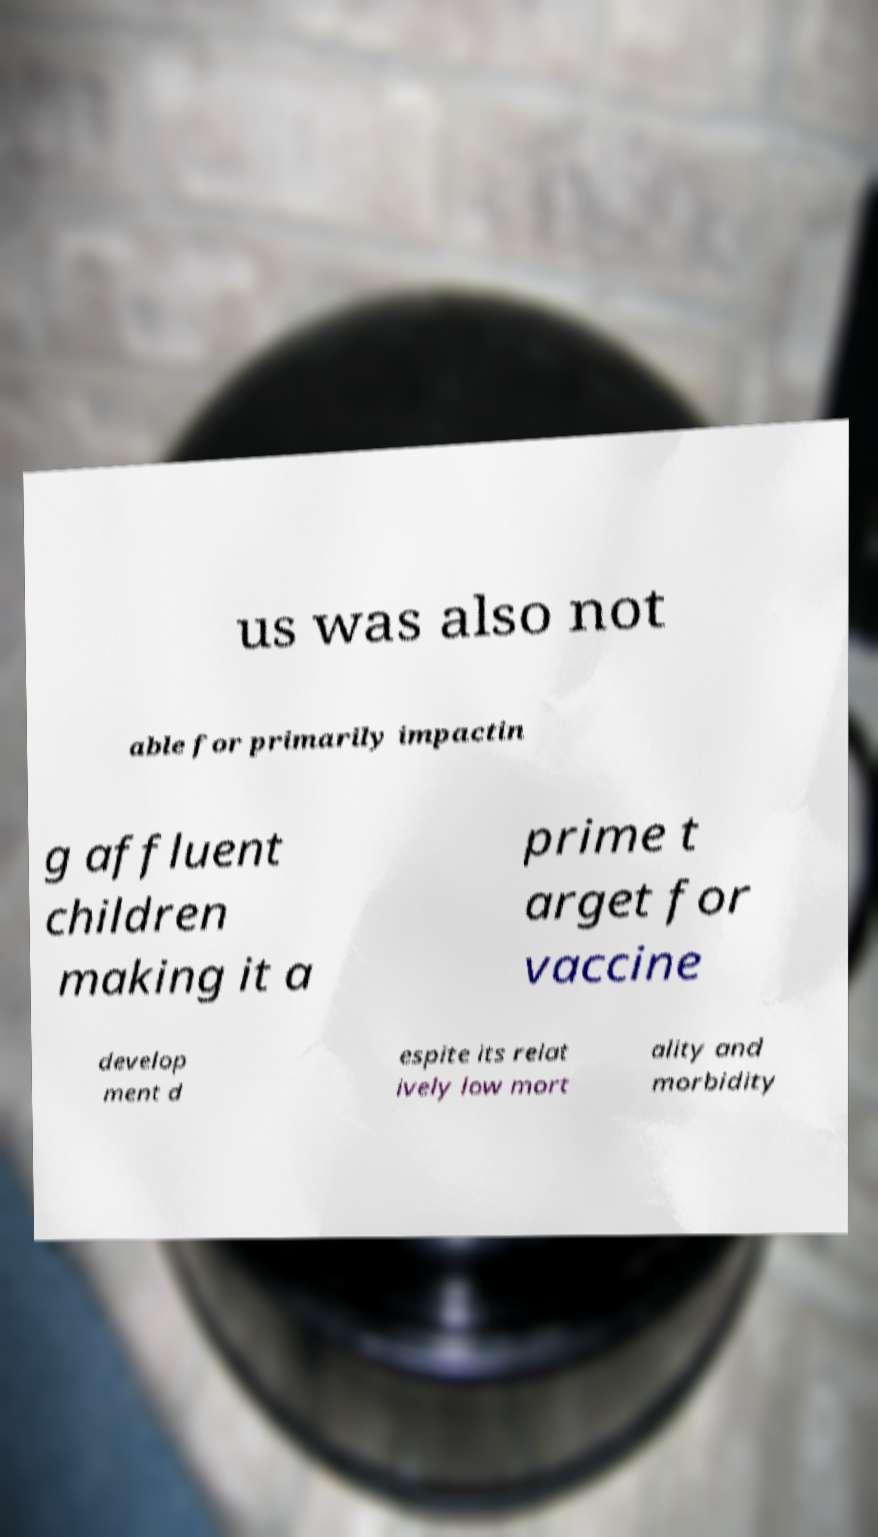Please identify and transcribe the text found in this image. us was also not able for primarily impactin g affluent children making it a prime t arget for vaccine develop ment d espite its relat ively low mort ality and morbidity 